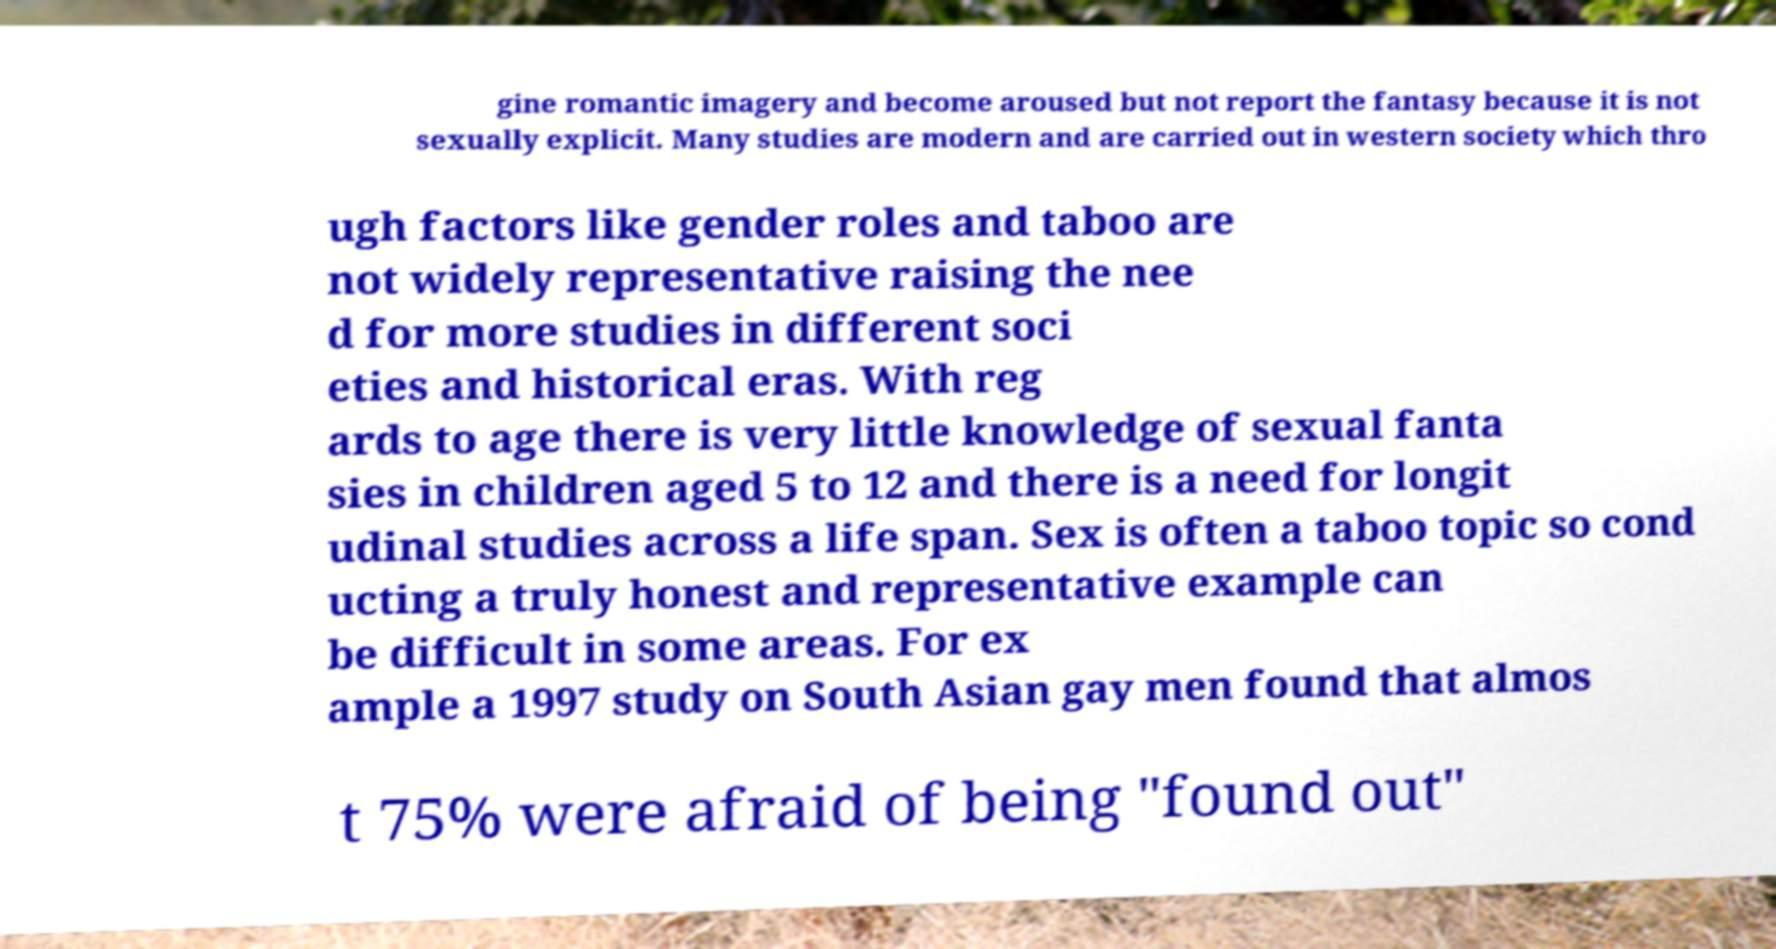Can you read and provide the text displayed in the image?This photo seems to have some interesting text. Can you extract and type it out for me? gine romantic imagery and become aroused but not report the fantasy because it is not sexually explicit. Many studies are modern and are carried out in western society which thro ugh factors like gender roles and taboo are not widely representative raising the nee d for more studies in different soci eties and historical eras. With reg ards to age there is very little knowledge of sexual fanta sies in children aged 5 to 12 and there is a need for longit udinal studies across a life span. Sex is often a taboo topic so cond ucting a truly honest and representative example can be difficult in some areas. For ex ample a 1997 study on South Asian gay men found that almos t 75% were afraid of being "found out" 